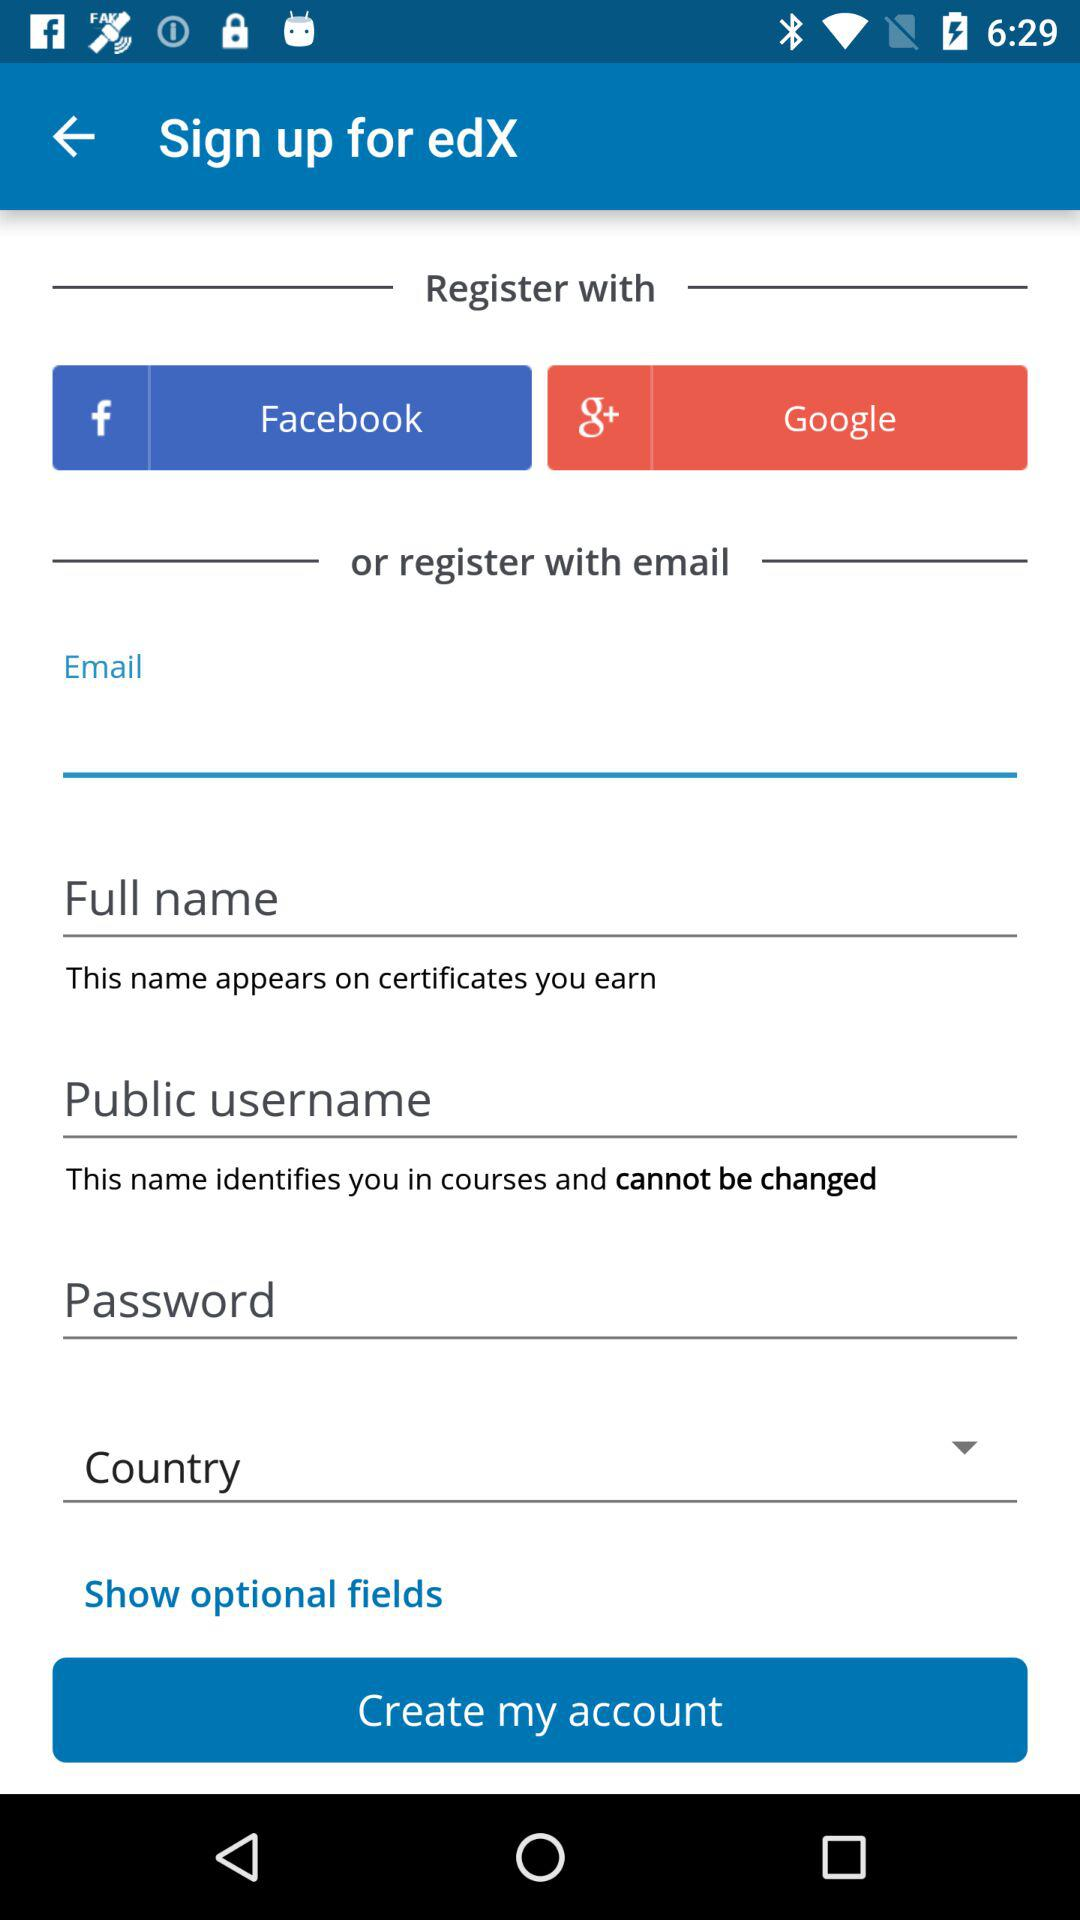Which options are given for registration? The given options for registration are "Facebook", "Google" and "email". 